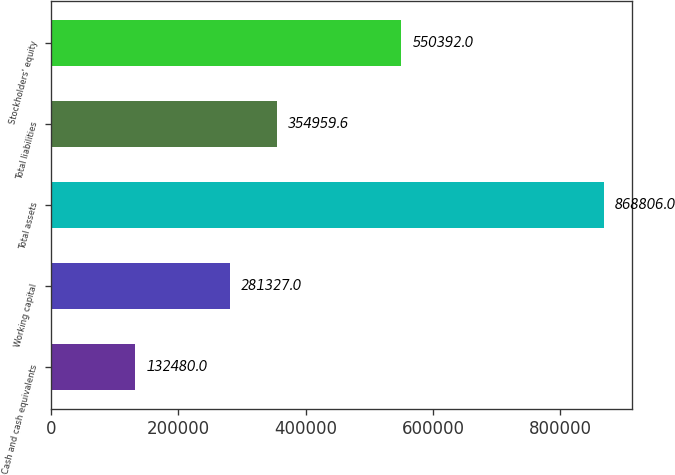<chart> <loc_0><loc_0><loc_500><loc_500><bar_chart><fcel>Cash and cash equivalents<fcel>Working capital<fcel>Total assets<fcel>Total liabilities<fcel>Stockholders' equity<nl><fcel>132480<fcel>281327<fcel>868806<fcel>354960<fcel>550392<nl></chart> 